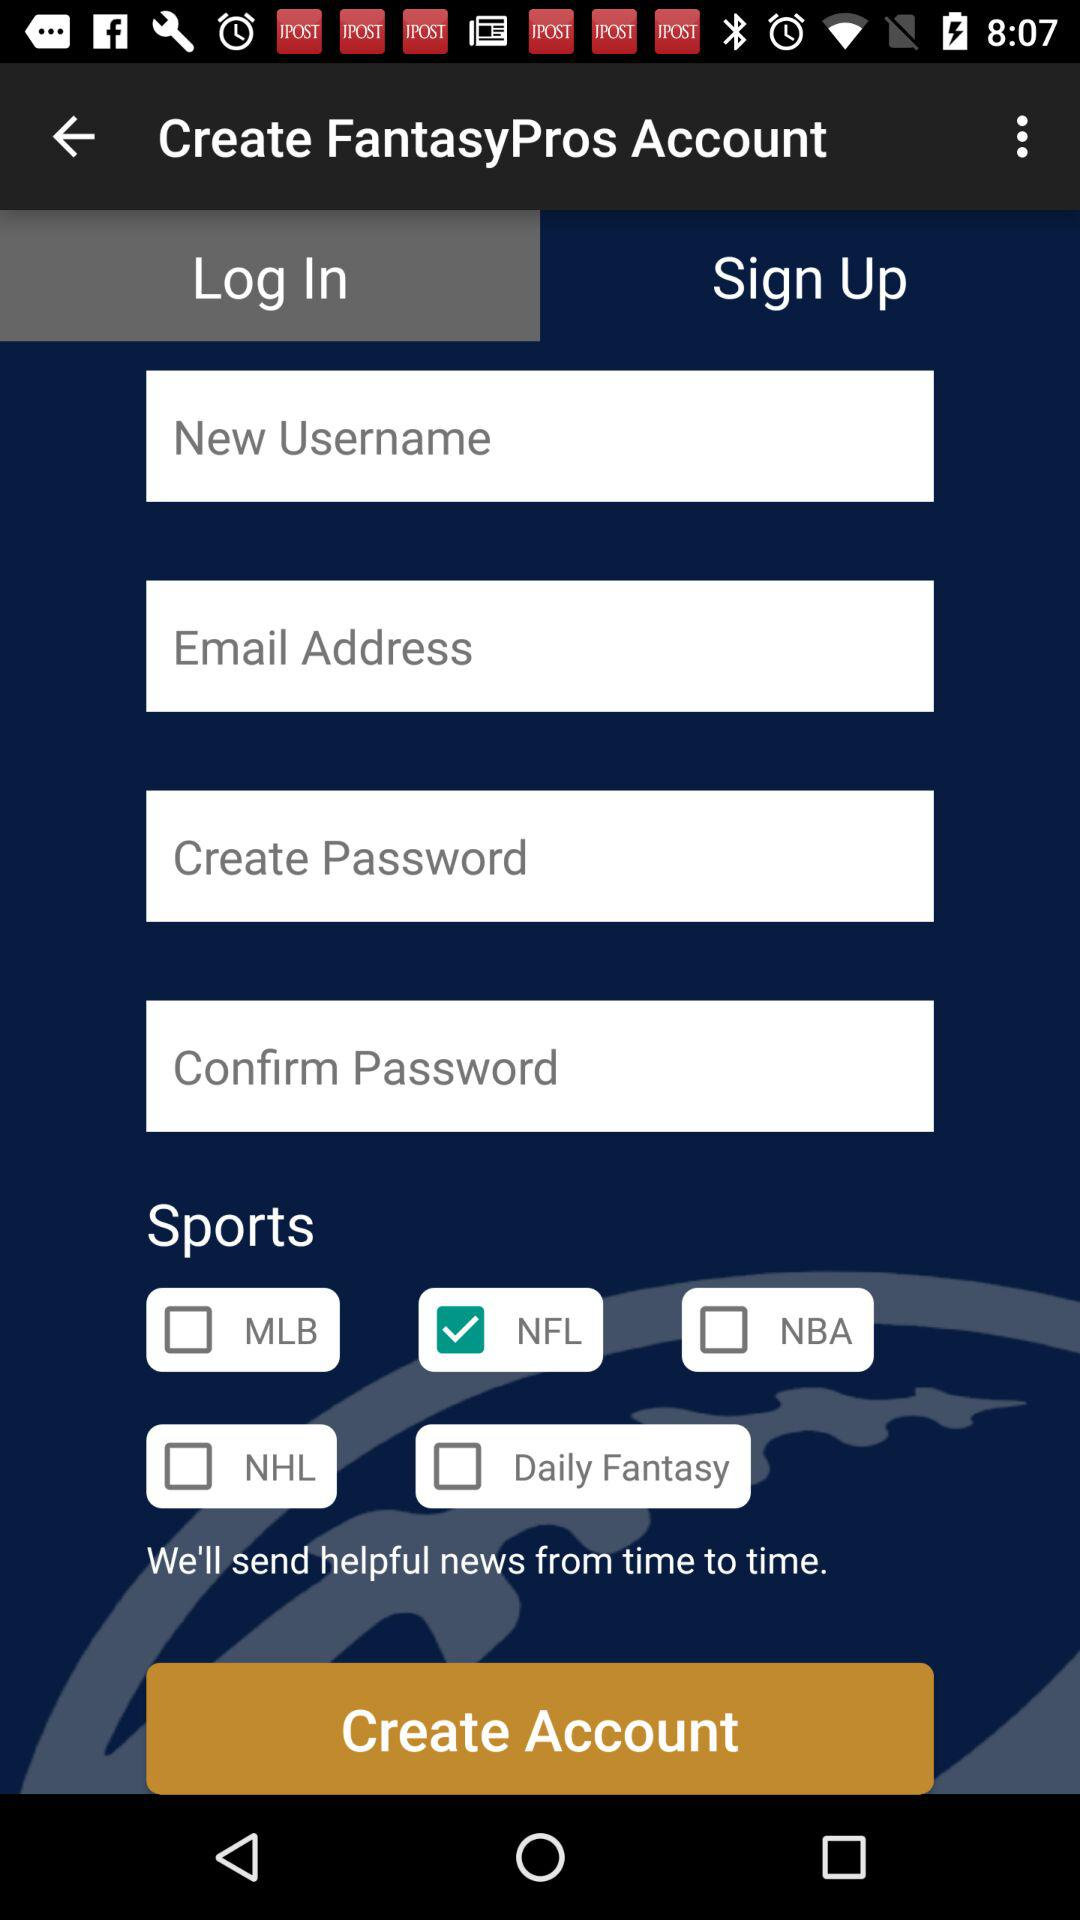What's the username?
When the provided information is insufficient, respond with <no answer>. <no answer> 